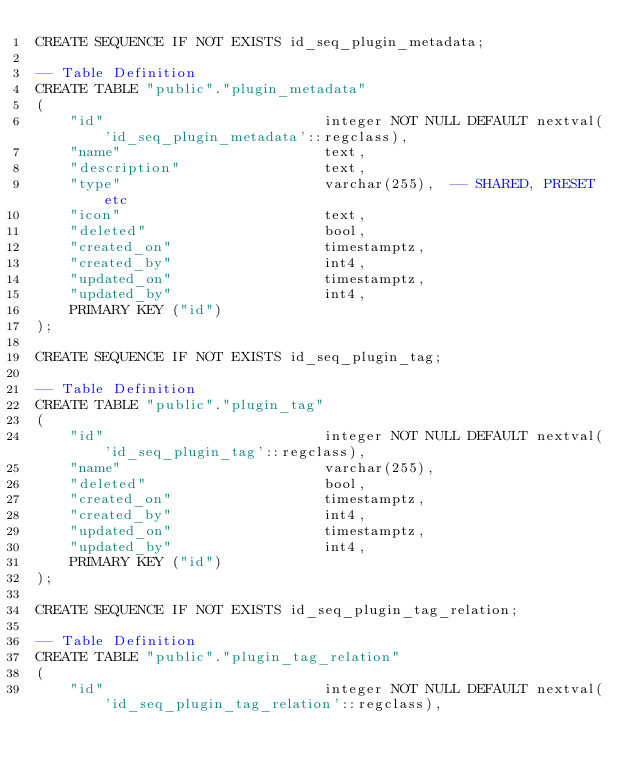<code> <loc_0><loc_0><loc_500><loc_500><_SQL_>CREATE SEQUENCE IF NOT EXISTS id_seq_plugin_metadata;

-- Table Definition
CREATE TABLE "public"."plugin_metadata"
(
    "id"                          integer NOT NULL DEFAULT nextval('id_seq_plugin_metadata'::regclass),
    "name"                        text,
    "description"                 text,
    "type"                        varchar(255),  -- SHARED, PRESET etc
    "icon"                        text,
    "deleted"                     bool,
    "created_on"                  timestamptz,
    "created_by"                  int4,
    "updated_on"                  timestamptz,
    "updated_by"                  int4,
    PRIMARY KEY ("id")
);

CREATE SEQUENCE IF NOT EXISTS id_seq_plugin_tag;

-- Table Definition
CREATE TABLE "public"."plugin_tag"
(
    "id"                          integer NOT NULL DEFAULT nextval('id_seq_plugin_tag'::regclass),
    "name"                        varchar(255),
    "deleted"                     bool,
    "created_on"                  timestamptz,
    "created_by"                  int4,
    "updated_on"                  timestamptz,
    "updated_by"                  int4,
    PRIMARY KEY ("id")
);

CREATE SEQUENCE IF NOT EXISTS id_seq_plugin_tag_relation;

-- Table Definition
CREATE TABLE "public"."plugin_tag_relation"
(
    "id"                          integer NOT NULL DEFAULT nextval('id_seq_plugin_tag_relation'::regclass),</code> 